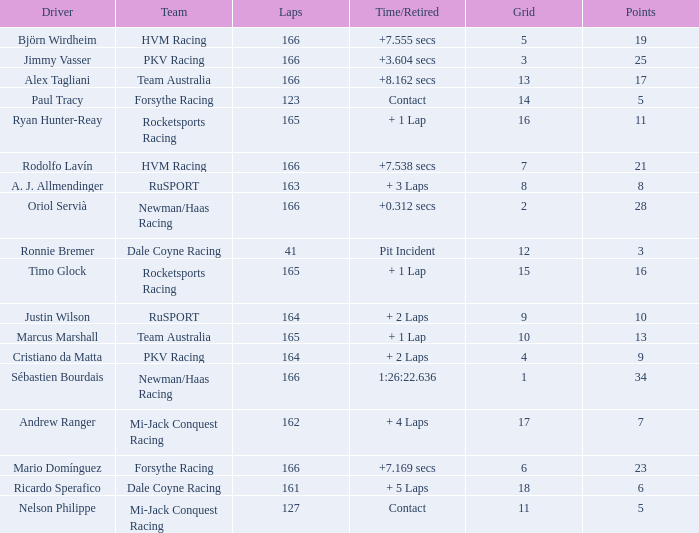What is the average points that the driver Ryan Hunter-Reay has? 11.0. 